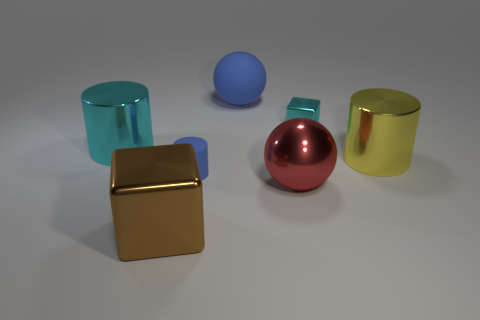There is a big thing that is the same color as the tiny matte thing; what is it made of?
Your response must be concise. Rubber. Does the large brown metallic thing that is to the right of the cyan cylinder have the same shape as the tiny cyan metal thing?
Provide a short and direct response. Yes. What number of things are either small cyan cubes or blocks behind the yellow metallic object?
Ensure brevity in your answer.  1. Are the block that is in front of the tiny cyan metal object and the large red object made of the same material?
Provide a succinct answer. Yes. Is there anything else that is the same size as the cyan shiny cylinder?
Make the answer very short. Yes. What is the material of the small object that is to the left of the big ball in front of the large blue object?
Your response must be concise. Rubber. Is the number of shiny cubes that are behind the small matte object greater than the number of objects that are in front of the matte ball?
Your response must be concise. No. The red thing has what size?
Offer a very short reply. Large. Is the color of the large sphere behind the large cyan cylinder the same as the metallic sphere?
Ensure brevity in your answer.  No. Is there any other thing that has the same shape as the red object?
Ensure brevity in your answer.  Yes. 